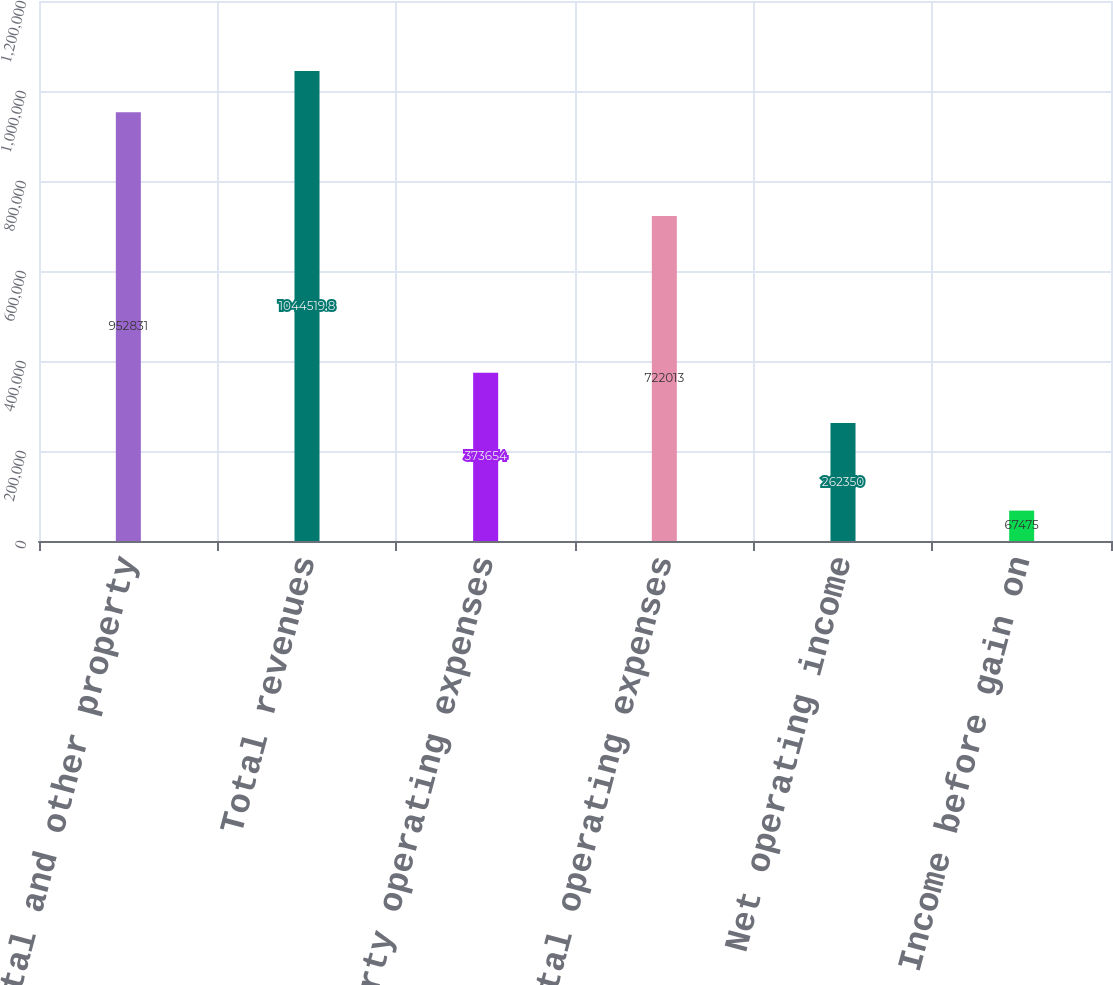<chart> <loc_0><loc_0><loc_500><loc_500><bar_chart><fcel>Rental and other property<fcel>Total revenues<fcel>Property operating expenses<fcel>Total operating expenses<fcel>Net operating income<fcel>Income before gain on<nl><fcel>952831<fcel>1.04452e+06<fcel>373654<fcel>722013<fcel>262350<fcel>67475<nl></chart> 